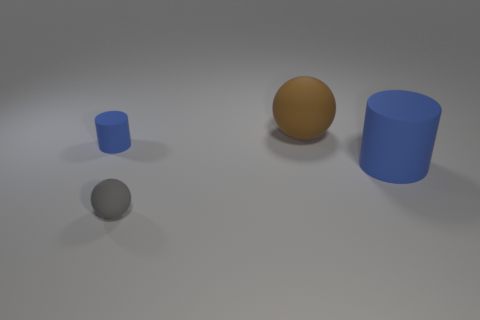Subtract all blue cylinders. How many were subtracted if there are1blue cylinders left? 1 Add 4 large brown matte spheres. How many objects exist? 8 Add 4 small blue cylinders. How many small blue cylinders are left? 5 Add 4 tiny cyan shiny cylinders. How many tiny cyan shiny cylinders exist? 4 Subtract 0 yellow spheres. How many objects are left? 4 Subtract all large red rubber things. Subtract all tiny blue rubber cylinders. How many objects are left? 3 